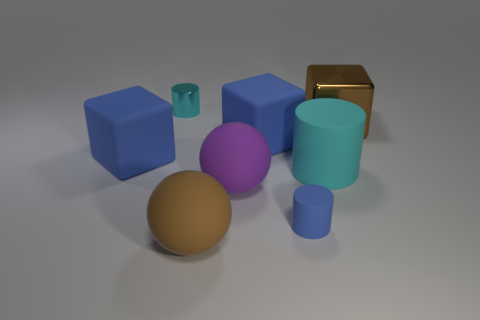What is the shape of the purple object that is the same material as the big brown ball?
Make the answer very short. Sphere. Is the material of the large blue thing that is right of the purple ball the same as the small cyan cylinder?
Give a very brief answer. No. How many other objects are there of the same material as the purple ball?
Your response must be concise. 5. How many objects are either large blocks that are right of the tiny cyan metallic cylinder or blue rubber objects behind the blue cylinder?
Ensure brevity in your answer.  3. Does the brown object to the right of the large cyan cylinder have the same shape as the small object that is in front of the large brown metallic object?
Offer a terse response. No. What is the shape of the purple matte thing that is the same size as the brown ball?
Keep it short and to the point. Sphere. What number of matte objects are large cyan cylinders or big balls?
Ensure brevity in your answer.  3. Does the brown object in front of the cyan rubber thing have the same material as the brown thing that is behind the small rubber thing?
Your response must be concise. No. There is a large block that is the same material as the tiny cyan cylinder; what color is it?
Your response must be concise. Brown. Are there more blocks left of the tiny matte cylinder than cyan matte cylinders that are in front of the purple object?
Offer a terse response. Yes. 